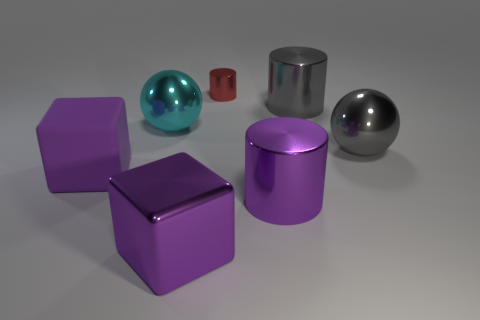What is the size of the red thing behind the large cyan metal thing?
Offer a very short reply. Small. What color is the large thing that is in front of the matte object and on the left side of the small thing?
Give a very brief answer. Purple. There is a gray thing that is behind the cyan shiny thing; is it the same size as the small cylinder?
Provide a short and direct response. No. There is a gray thing on the left side of the big gray ball; is there a large purple cylinder that is right of it?
Provide a succinct answer. No. What is the material of the gray ball?
Your answer should be very brief. Metal. Are there any large things on the right side of the small red metallic object?
Ensure brevity in your answer.  Yes. Is the number of big metal balls that are to the left of the purple metallic cylinder the same as the number of purple metal cubes that are on the right side of the metallic cube?
Your answer should be very brief. No. How many large yellow metallic blocks are there?
Your answer should be very brief. 0. Is the number of big shiny things to the left of the gray ball greater than the number of shiny spheres?
Your answer should be compact. Yes. There is a purple cube on the right side of the big cyan ball; what is it made of?
Offer a very short reply. Metal. 